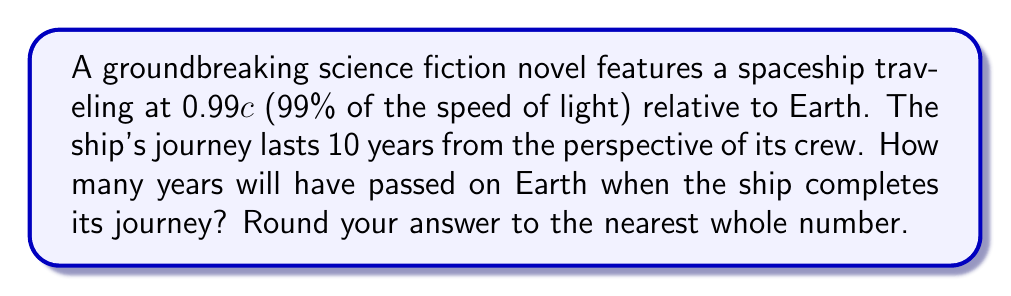Can you answer this question? To solve this problem, we need to use the time dilation formula from special relativity. The steps are as follows:

1) The time dilation formula is:

   $$t' = \frac{t}{\sqrt{1-\frac{v^2}{c^2}}}$$

   Where:
   $t'$ is the time passed on Earth
   $t$ is the time passed on the spaceship
   $v$ is the velocity of the spaceship
   $c$ is the speed of light

2) We know that:
   $t = 10$ years
   $v = 0.99c$

3) Substituting these values into the formula:

   $$t' = \frac{10}{\sqrt{1-\frac{(0.99c)^2}{c^2}}}$$

4) Simplify inside the square root:

   $$t' = \frac{10}{\sqrt{1-0.99^2}}$$

5) Calculate:

   $$t' = \frac{10}{\sqrt{1-0.9801}} = \frac{10}{\sqrt{0.0199}} = \frac{10}{0.1411} \approx 70.87$$

6) Rounding to the nearest whole number:

   $t' \approx 71$ years
Answer: 71 years 